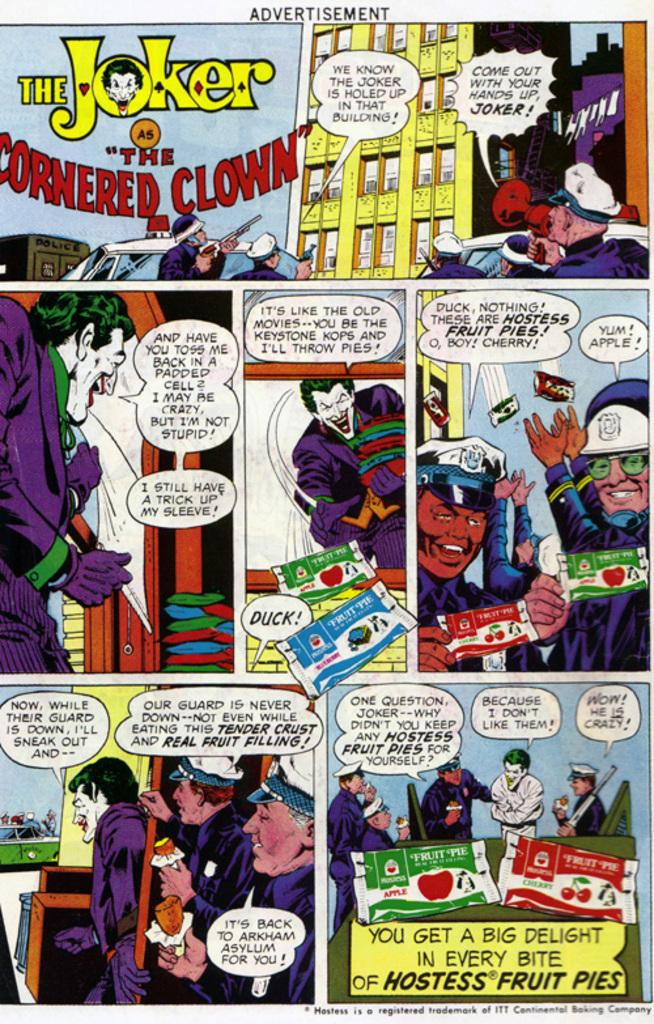<image>
Present a compact description of the photo's key features. An advertisement for Hostess Fruit Pies featuring The Joker. 